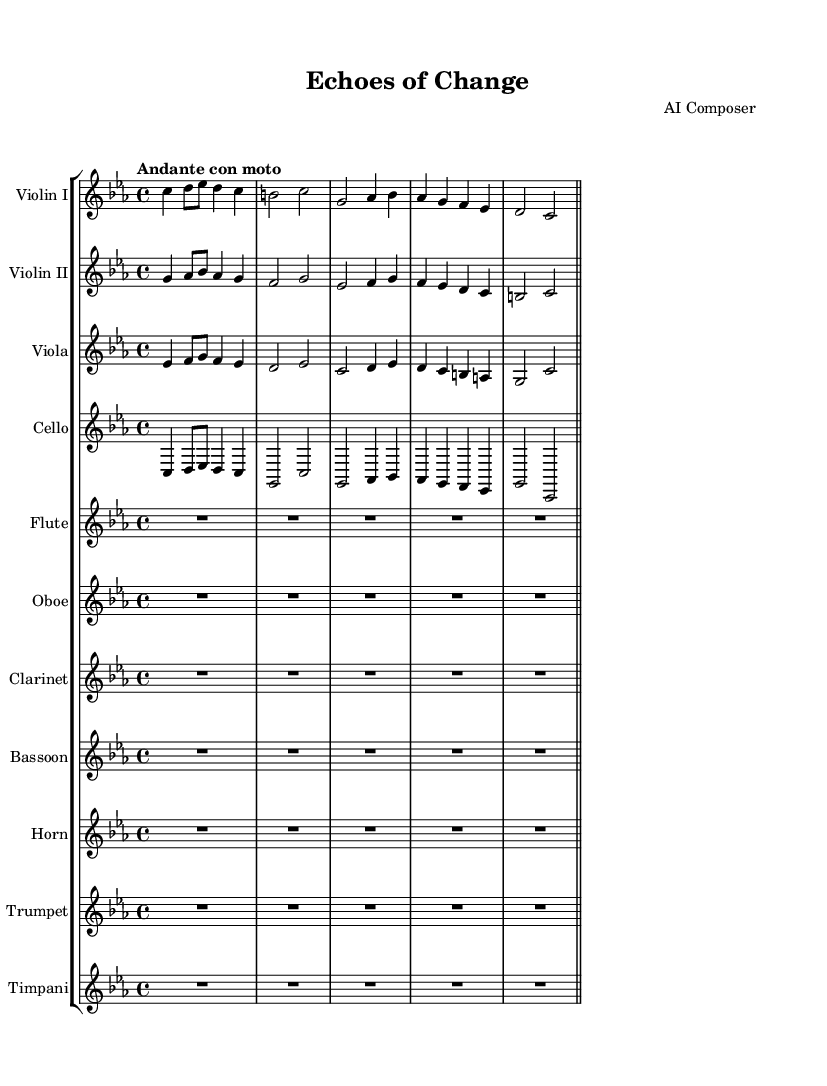What is the key signature of this music? The key signature is indicated at the beginning of the staff, showing 3 flats (B, E, and A), which indicates C minor.
Answer: C minor What is the time signature? The time signature is found at the beginning of the score, represented as "4/4", which means there are four beats in each measure, and the quarter note gets one beat.
Answer: 4/4 What is the tempo marking of this piece? The tempo marking is displayed at the beginning of the score, indicating the piece should be played at a moderate pace denoted as "Andante con moto".
Answer: Andante con moto Which instruments are included in this symphony? The list of instruments is found in the score, detailing strings and woodwinds, specifically: Violin I, Violin II, Viola, Cello, Flute, Oboe, Clarinet, Bassoon, Horn, Trumpet, and Timpani.
Answer: 11 instruments How many measures are there for the flute part? The flute part shows 5 measures of rest, indicated by "R1*5", meaning the flute does not play during these measures.
Answer: 5 measures Are there any dynamics indicated in the score? Upon examining the score, there are no specific dynamics marked, which means the performance dynamics will be left to the interpretation of the conductor.
Answer: No dynamics indicated What type of composition is this piece classified as? The title of the score is "Echoes of Change", which suggests a thematic focus on governmental transition, matching the structure of a symphonic style in classical music.
Answer: Symphony 